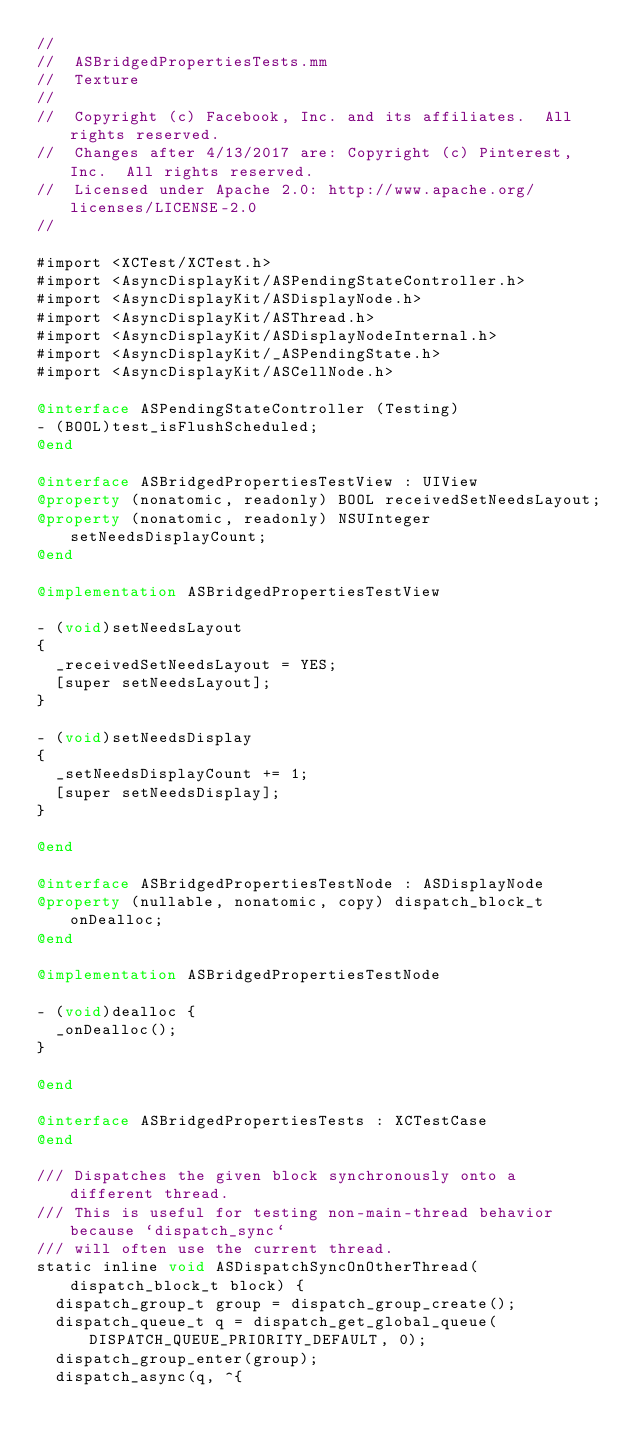Convert code to text. <code><loc_0><loc_0><loc_500><loc_500><_ObjectiveC_>//
//  ASBridgedPropertiesTests.mm
//  Texture
//
//  Copyright (c) Facebook, Inc. and its affiliates.  All rights reserved.
//  Changes after 4/13/2017 are: Copyright (c) Pinterest, Inc.  All rights reserved.
//  Licensed under Apache 2.0: http://www.apache.org/licenses/LICENSE-2.0
//

#import <XCTest/XCTest.h>
#import <AsyncDisplayKit/ASPendingStateController.h>
#import <AsyncDisplayKit/ASDisplayNode.h>
#import <AsyncDisplayKit/ASThread.h>
#import <AsyncDisplayKit/ASDisplayNodeInternal.h>
#import <AsyncDisplayKit/_ASPendingState.h>
#import <AsyncDisplayKit/ASCellNode.h>

@interface ASPendingStateController (Testing)
- (BOOL)test_isFlushScheduled;
@end

@interface ASBridgedPropertiesTestView : UIView
@property (nonatomic, readonly) BOOL receivedSetNeedsLayout;
@property (nonatomic, readonly) NSUInteger setNeedsDisplayCount;
@end

@implementation ASBridgedPropertiesTestView

- (void)setNeedsLayout
{
  _receivedSetNeedsLayout = YES;
  [super setNeedsLayout];
}

- (void)setNeedsDisplay
{
  _setNeedsDisplayCount += 1;
  [super setNeedsDisplay];
}

@end

@interface ASBridgedPropertiesTestNode : ASDisplayNode
@property (nullable, nonatomic, copy) dispatch_block_t onDealloc;
@end

@implementation ASBridgedPropertiesTestNode

- (void)dealloc {
  _onDealloc();
}

@end

@interface ASBridgedPropertiesTests : XCTestCase
@end

/// Dispatches the given block synchronously onto a different thread.
/// This is useful for testing non-main-thread behavior because `dispatch_sync`
/// will often use the current thread.
static inline void ASDispatchSyncOnOtherThread(dispatch_block_t block) {
  dispatch_group_t group = dispatch_group_create();
  dispatch_queue_t q = dispatch_get_global_queue(DISPATCH_QUEUE_PRIORITY_DEFAULT, 0);
  dispatch_group_enter(group);
  dispatch_async(q, ^{</code> 